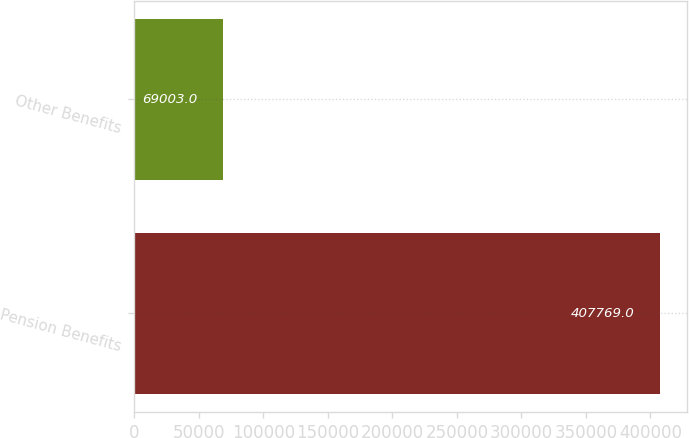<chart> <loc_0><loc_0><loc_500><loc_500><bar_chart><fcel>Pension Benefits<fcel>Other Benefits<nl><fcel>407769<fcel>69003<nl></chart> 